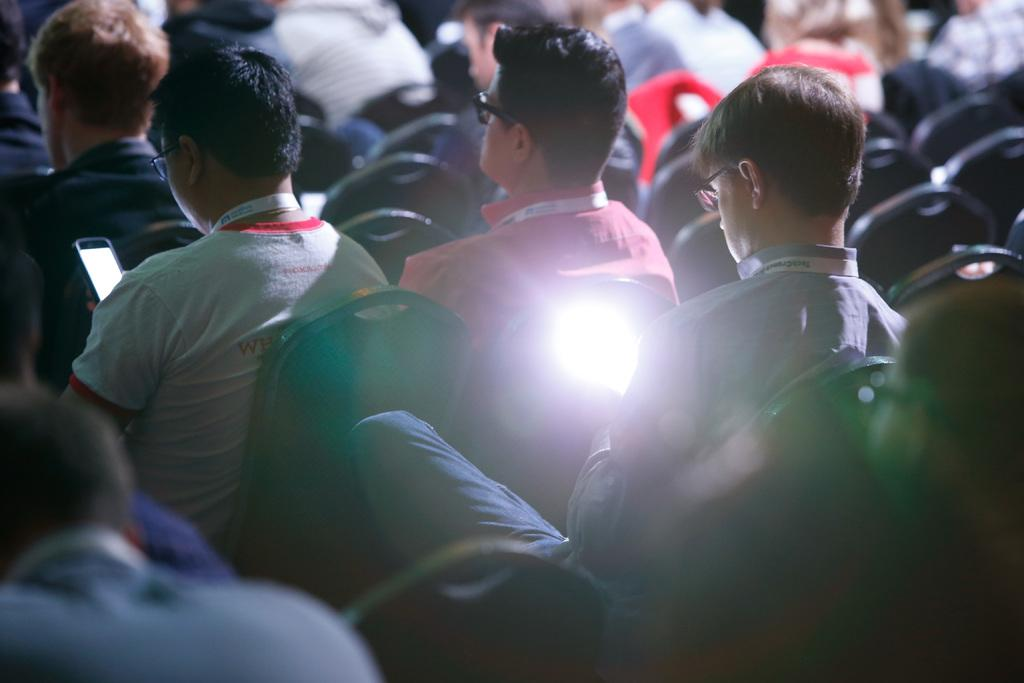What is the main subject of the image? The main subject of the image is a group of people. What are the people in the image doing? The people are seated on chairs. Are there any objects being held by the people in the image? Yes, some people are holding mobile devices. What type of lipstick is the grandmother wearing in the image? There is no grandmother or lipstick present in the image. 